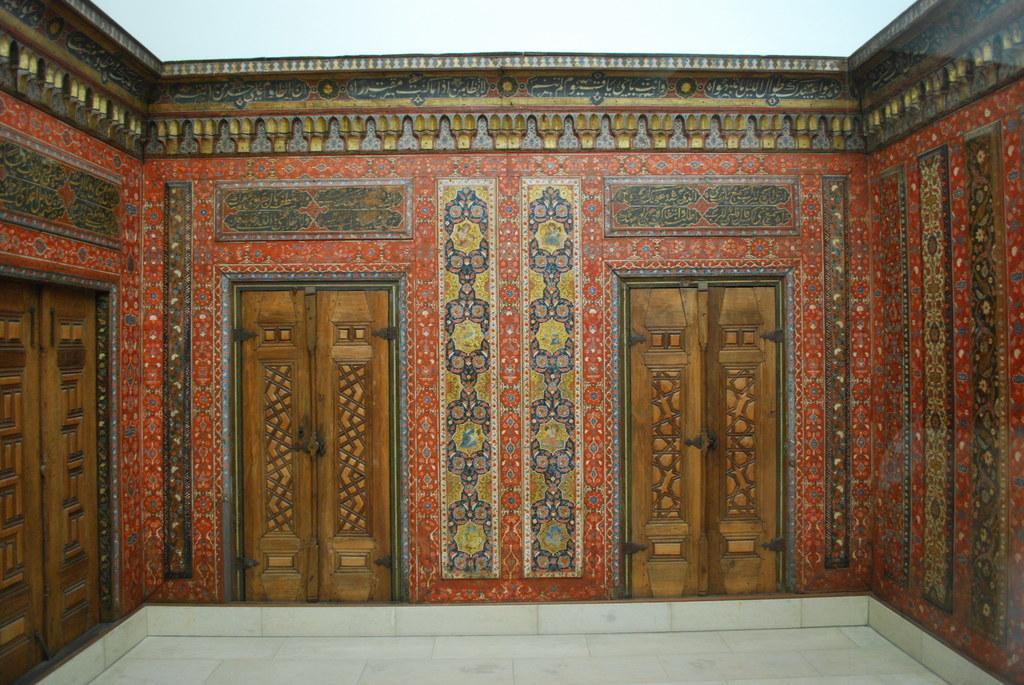Describe this image in one or two sentences. In this image, in the middle, we can see two doors which are closed. On the left side, we can also see a door which is closed. In the background, we can see a wall with some painting. At the top, we can see white color. At the bottom, we can see a floor. 